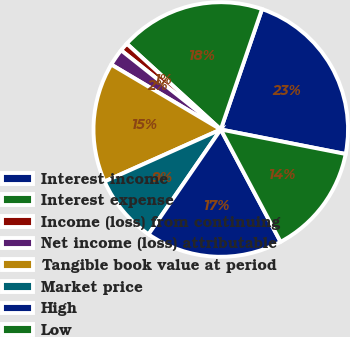Convert chart to OTSL. <chart><loc_0><loc_0><loc_500><loc_500><pie_chart><fcel>Interest income<fcel>Interest expense<fcel>Income (loss) from continuing<fcel>Net income (loss) attributable<fcel>Tangible book value at period<fcel>Market price<fcel>High<fcel>Low<nl><fcel>22.83%<fcel>18.48%<fcel>1.09%<fcel>2.17%<fcel>15.22%<fcel>8.7%<fcel>17.39%<fcel>14.13%<nl></chart> 